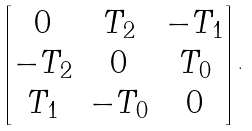Convert formula to latex. <formula><loc_0><loc_0><loc_500><loc_500>\begin{bmatrix} 0 & T _ { 2 } & - T _ { 1 } \\ - T _ { 2 } & 0 & T _ { 0 } \\ T _ { 1 } & - T _ { 0 } & 0 \end{bmatrix} .</formula> 